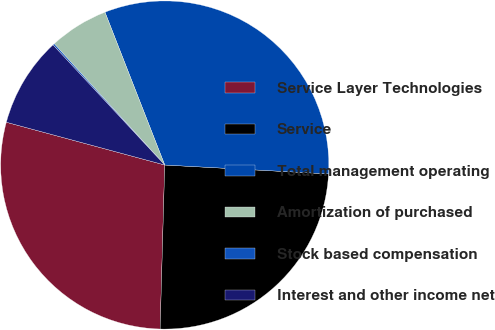Convert chart to OTSL. <chart><loc_0><loc_0><loc_500><loc_500><pie_chart><fcel>Service Layer Technologies<fcel>Service<fcel>Total management operating<fcel>Amortization of purchased<fcel>Stock based compensation<fcel>Interest and other income net<nl><fcel>28.75%<fcel>24.58%<fcel>31.8%<fcel>5.83%<fcel>0.16%<fcel>8.88%<nl></chart> 